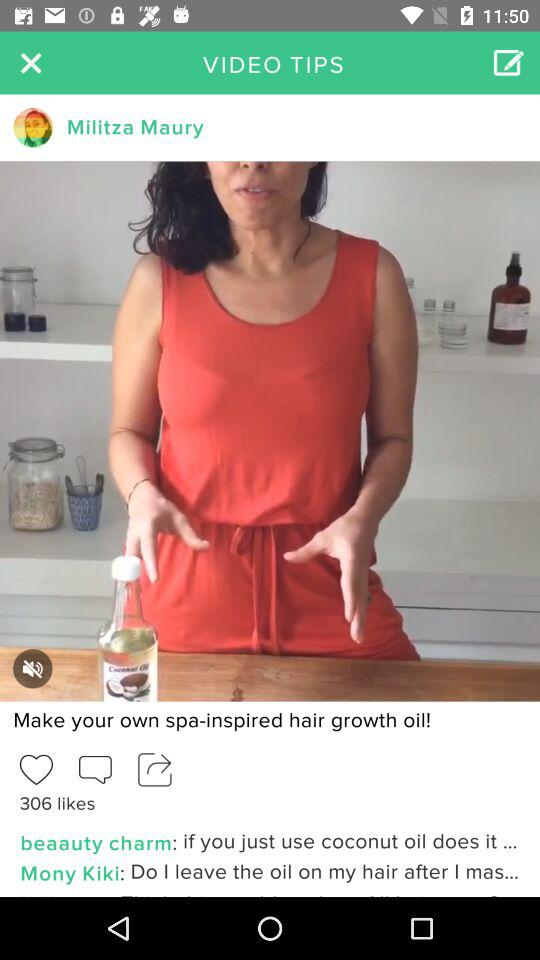How many likes are there on the video?
Answer the question using a single word or phrase. 306 